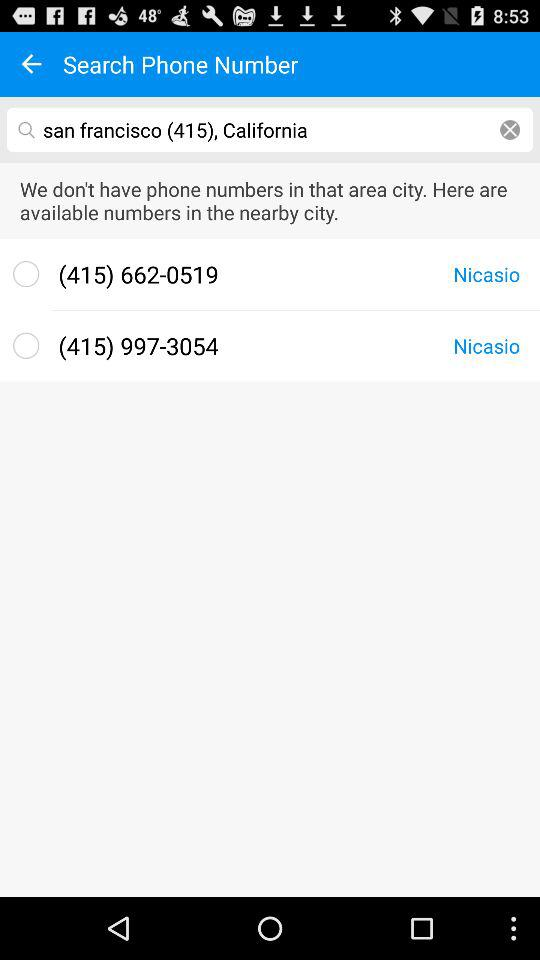What are the available phone numbers in the nearby city? The available phone numbers in the nearby city are (415) 662-0519 and (415) 997-3054. 